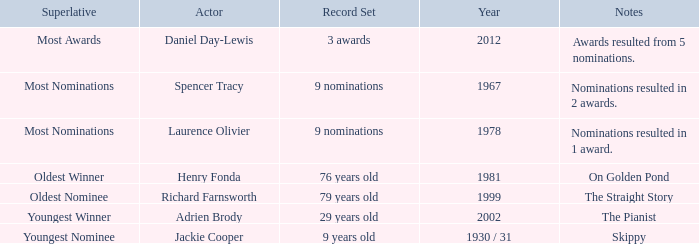What are the notes in 1981? On Golden Pond. 